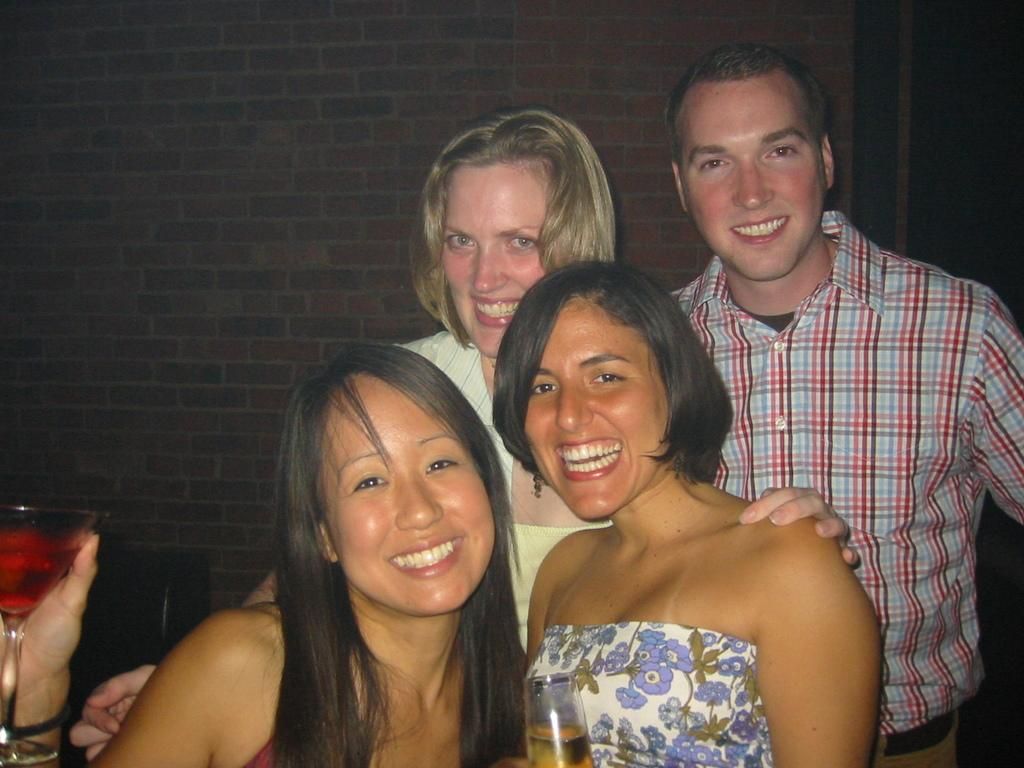How many people are in the image? There are four people in the image: three women and one man. What are the individuals doing in the image? The individuals are standing together. What expressions do the people have in the image? They are all smiling. What are two of the women holding in the image? Two of the women are holding glasses with alcohol. Where is the kitty in the image? There is no kitty present in the image. What type of health advice can be seen in the image? There is no health advice present in the image. 